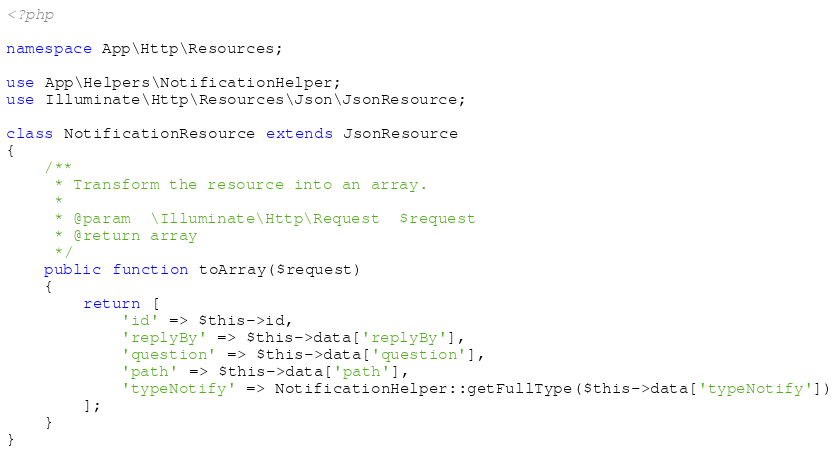Convert code to text. <code><loc_0><loc_0><loc_500><loc_500><_PHP_><?php

namespace App\Http\Resources;

use App\Helpers\NotificationHelper;
use Illuminate\Http\Resources\Json\JsonResource;

class NotificationResource extends JsonResource
{
    /**
     * Transform the resource into an array.
     *
     * @param  \Illuminate\Http\Request  $request
     * @return array
     */
    public function toArray($request)
    {
        return [
            'id' => $this->id,
            'replyBy' => $this->data['replyBy'],
            'question' => $this->data['question'],
            'path' => $this->data['path'],
            'typeNotify' => NotificationHelper::getFullType($this->data['typeNotify'])
        ];
    }
}
</code> 